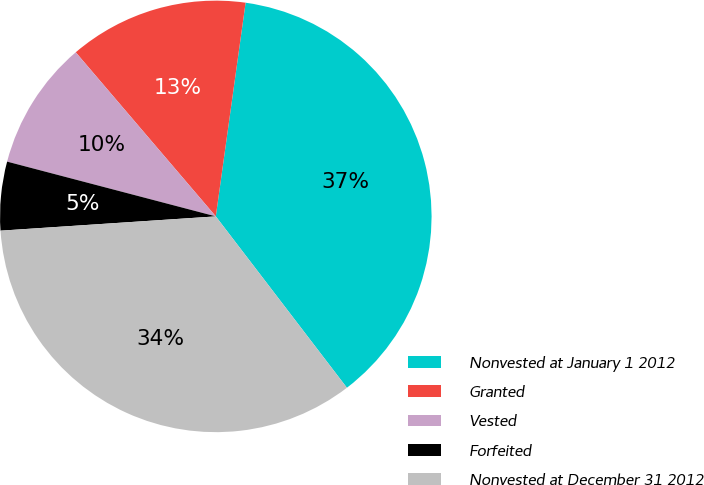Convert chart. <chart><loc_0><loc_0><loc_500><loc_500><pie_chart><fcel>Nonvested at January 1 2012<fcel>Granted<fcel>Vested<fcel>Forfeited<fcel>Nonvested at December 31 2012<nl><fcel>37.4%<fcel>13.45%<fcel>9.67%<fcel>5.14%<fcel>34.34%<nl></chart> 